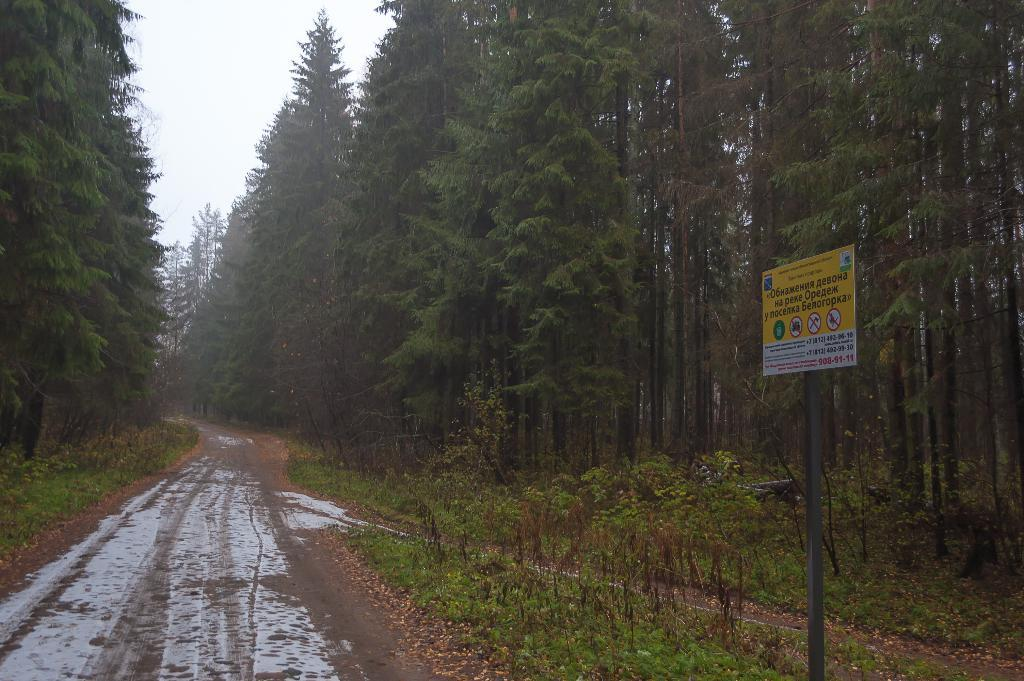What is the main feature in the middle of the image? There is a path in the middle of the image. What type of vegetation is present on either side of the path? Trees are present on either side of the path. What safety measure is visible on the right side of the path? There is a caution board on the right side of the path. What type of pleasure can be seen enjoying the leaves on the trees in the image? There are no people or animals visible in the image, and therefore no pleasure can be seen enjoying the leaves on the trees. 